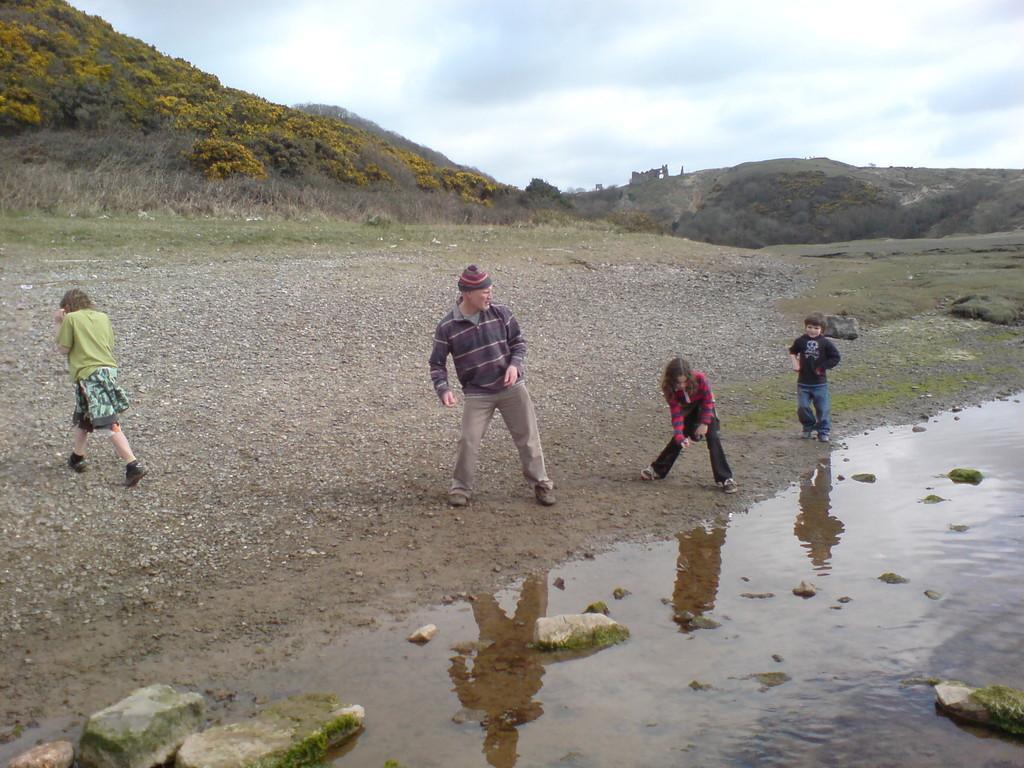Could you give a brief overview of what you see in this image? There are four people standing. I can see the water. These look like the hills. I can see the trees and bushes. This is the sky. 